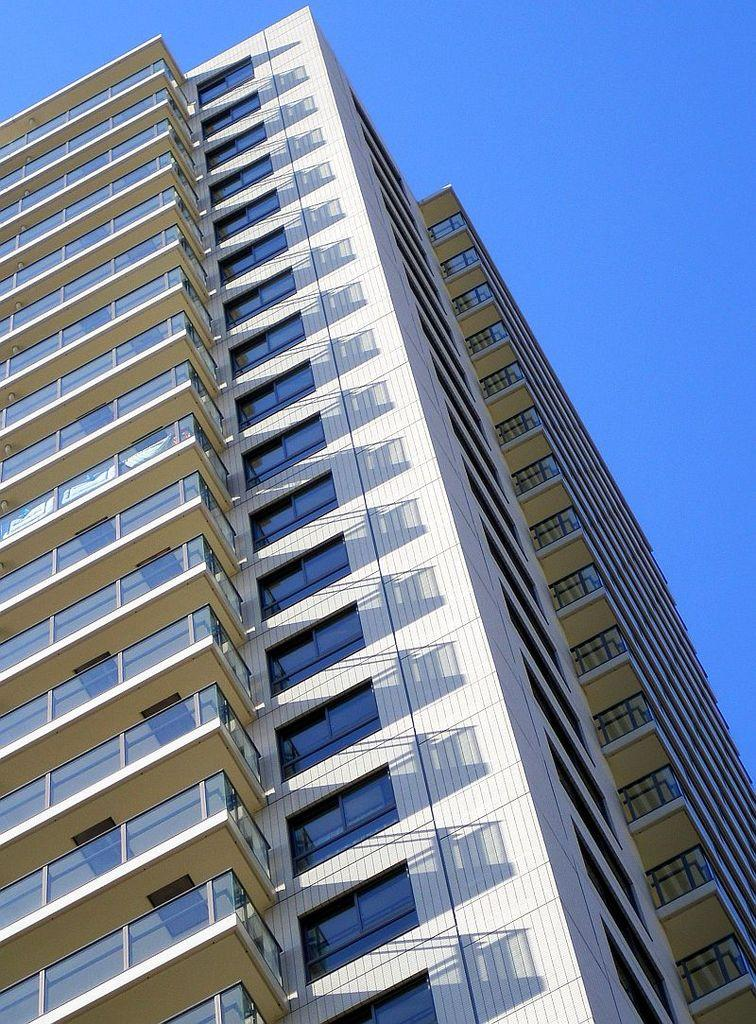What is the main structure in the image? There is a big building in the image. What are some features of the building? The building has plenty of windows and balconies. What can be seen in the background of the image? The sky is visible in the background of the image. What type of lunch is being served on the balcony in the image? There is no lunch or balcony present in the image; it only features a big building with windows and balconies. Can you tell me how many divisions are visible in the building? The image does not provide information about the number of divisions in the building; it only shows the building's exterior with windows and balconies. 